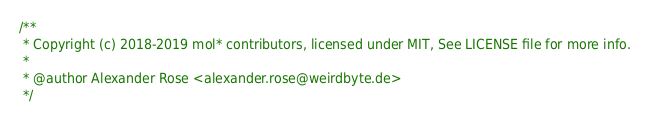Convert code to text. <code><loc_0><loc_0><loc_500><loc_500><_JavaScript_>/**
 * Copyright (c) 2018-2019 mol* contributors, licensed under MIT, See LICENSE file for more info.
 *
 * @author Alexander Rose <alexander.rose@weirdbyte.de>
 */</code> 